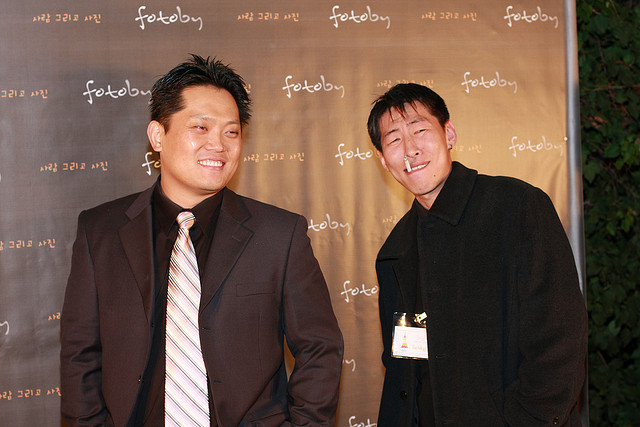Identify the text contained in this image. fotoby Fotoby fotoby Fotoby fotoby foto toby foto fe fotobn 